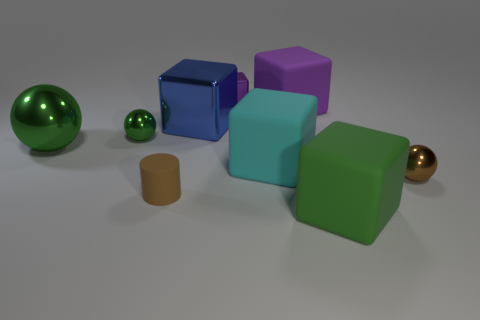What number of objects are either tiny balls that are to the right of the big purple object or balls that are to the right of the cylinder?
Make the answer very short. 1. What is the color of the cylinder?
Provide a succinct answer. Brown. What number of big green balls have the same material as the brown cylinder?
Provide a succinct answer. 0. Are there more large matte blocks than big purple rubber things?
Offer a very short reply. Yes. There is a shiny ball in front of the large green metallic object; what number of big green metal spheres are in front of it?
Your answer should be compact. 0. How many things are either tiny brown objects on the right side of the tiny block or gray cylinders?
Provide a succinct answer. 1. Is there a big brown shiny thing of the same shape as the tiny brown shiny thing?
Offer a terse response. No. What shape is the small brown object on the left side of the big rubber object that is in front of the brown shiny ball?
Make the answer very short. Cylinder. How many cylinders are tiny objects or tiny purple shiny things?
Give a very brief answer. 1. There is another block that is the same color as the small block; what material is it?
Keep it short and to the point. Rubber. 